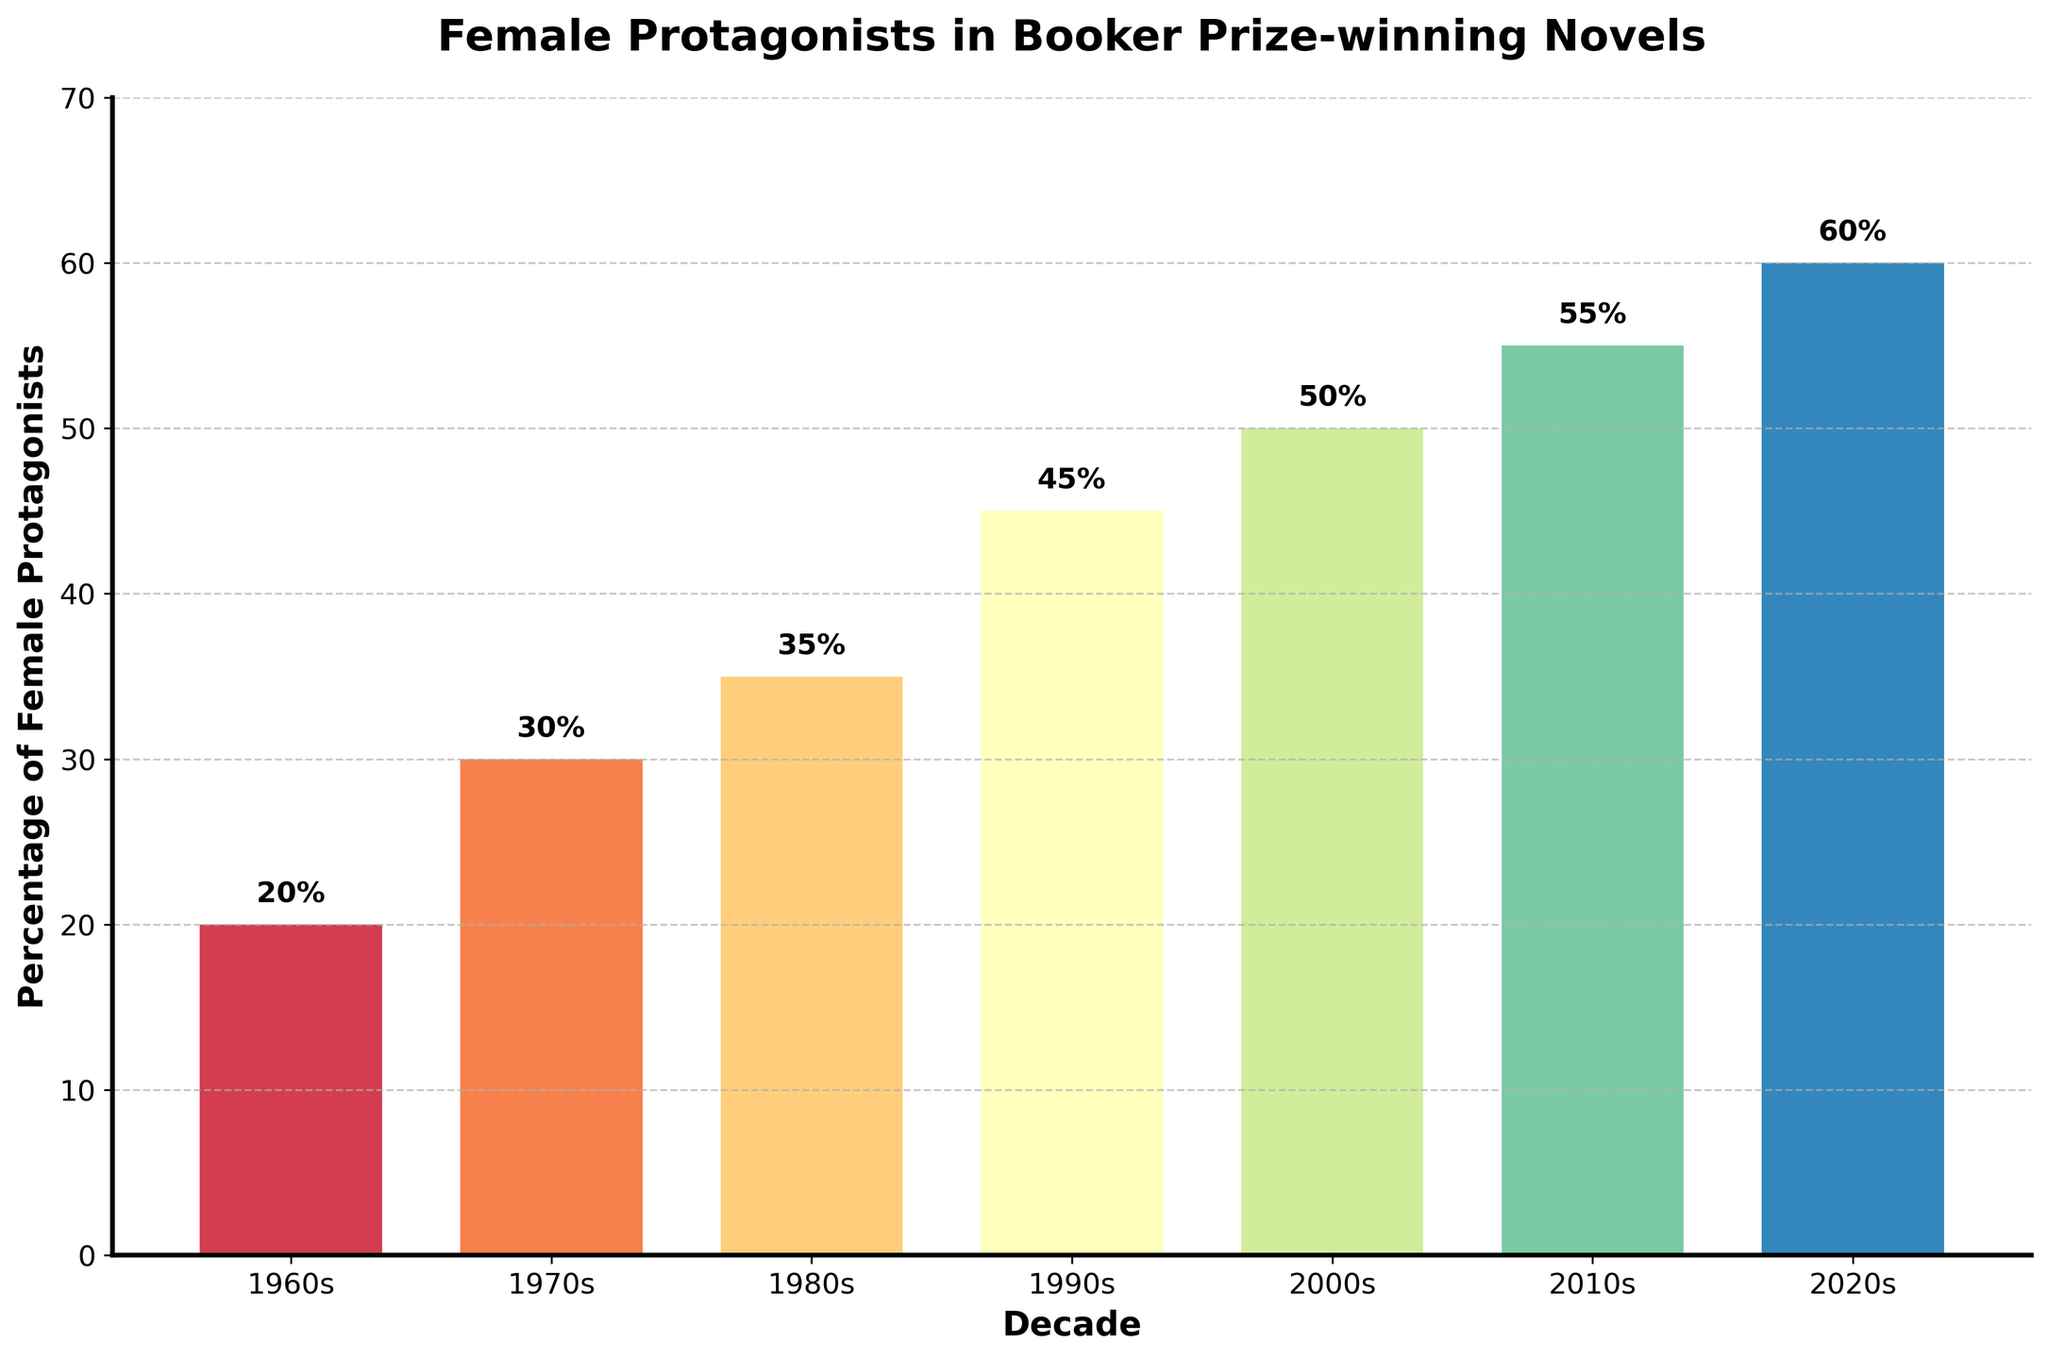What is the percentage increase in female protagonists from the 1960s to the 2020s? To find the percentage increase, subtract the percentage in the 1960s from the percentage in the 2020s, then divide by the percentage in the 1960s and multiply by 100: (60 - 20) / 20 * 100 = 200%
Answer: 200% In which decade did the percentage of female protagonists first exceed 50%? Look for the first decade where the percentage is above 50%. It crosses 50% in the 2010s.
Answer: 2010s By how much did the percentage of female protagonists increase from the 1980s to the 1990s? Subtract the percentage in the 1980s from the percentage in the 1990s: 45 - 35 = 10%
Answer: 10% Which decade had the smallest increase in the percentage of female protagonists compared to the previous decade? Compare the percentage increases from each decade to its previous one and find the smallest value. The smallest increase is from the 1970s to the 1980s: 35 - 30 = 5%
Answer: 1980s What is the average percentage of female protagonists across all decades shown? Sum all the decades' percentages and divide by the number of decades: (20 + 30 + 35 + 45 + 50 + 55 + 60) / 7 ≈ 42.14%
Answer: 42.14% Which decade showed the highest growth in female protagonist representation? Find the difference between consecutive decades and identify the maximum growth: from the 2000s to the 2010s: 55 - 50 = 5%
Answer: 2010s How many decades had a percentage of female protagonists below 40%? Identify the decades with percentages below 40%, these are: 1960s (20%), 1970s (30%), and 1980s (35%) – a total of 3 decades.
Answer: 3 In which decade is the bar colored the darkest? The color intensity increases progressively from the lightest in the 1960s to the darkest in the 2020s.
Answer: 2020s What is the sum of the percentages of female protagonists from the 1990s to the 2010s? Sum the percentages for the 1990s, 2000s, and 2010s: 45 + 50 + 55 = 150%
Answer: 150% Compare the height of the bars for the 2000s and 2010s. Which one is taller? The bar for the 2010s is taller at 55%, compared to the 2000s at 50%.
Answer: 2010s 